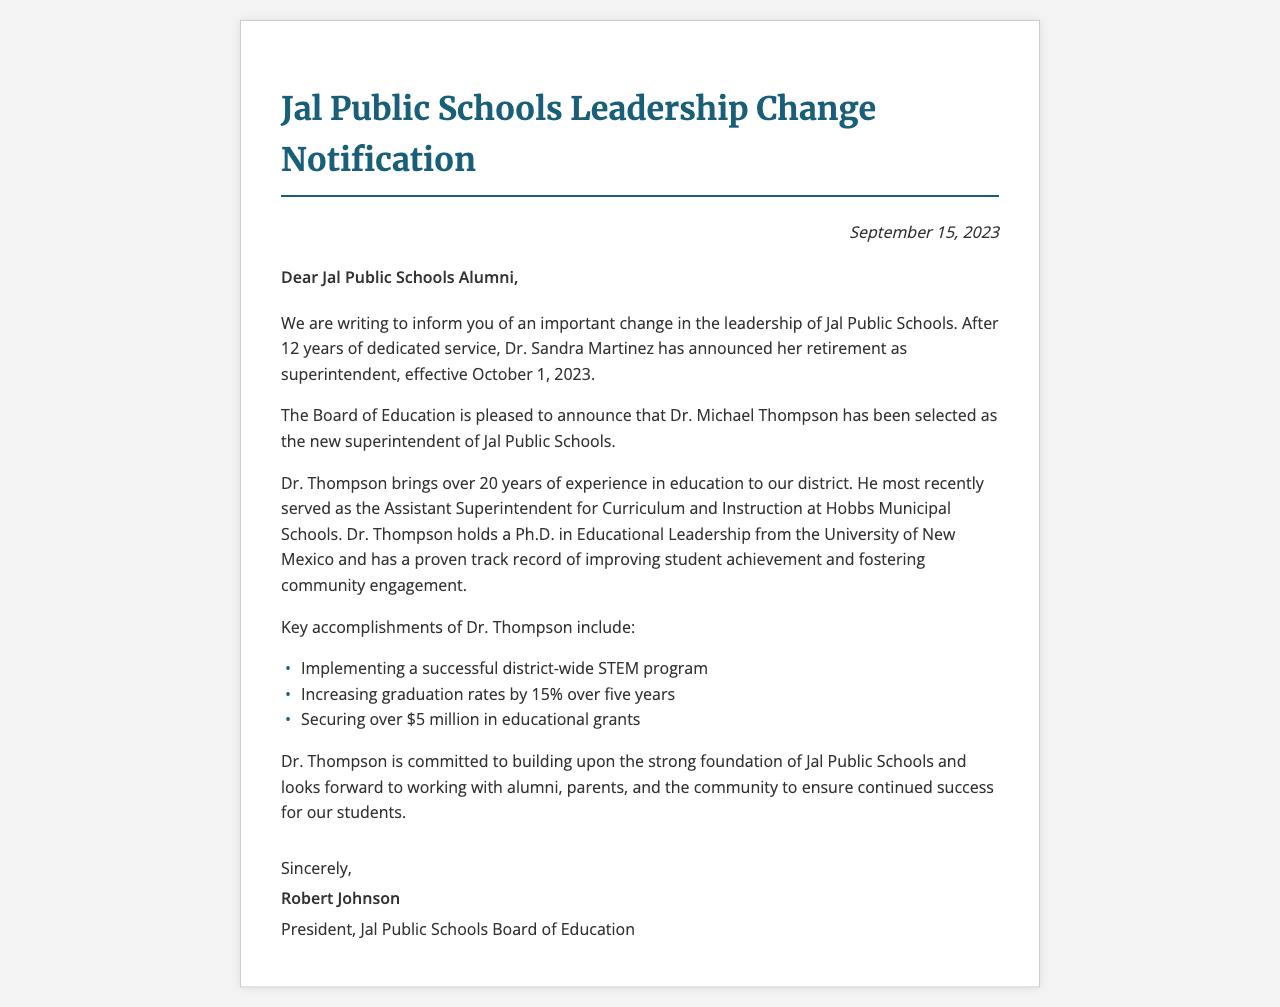What is the date of the notification? The date of the notification is clearly mentioned in the document.
Answer: September 15, 2023 Who announced their retirement? The document states who is retiring from their position as superintendent.
Answer: Dr. Sandra Martinez What is the effective date of Dr. Martinez's retirement? The document specifies when Dr. Martinez's retirement will take effect.
Answer: October 1, 2023 Who is the new superintendent? The name of the newly appointed superintendent is provided in the document.
Answer: Dr. Michael Thompson How many years of experience does Dr. Thompson have in education? The document outlines Dr. Thompson's years of experience in the education field.
Answer: Over 20 years Where did Dr. Thompson serve prior to his new position? The document mentions Dr. Thompson's previous role before being appointed superintendent.
Answer: Hobbs Municipal Schools What degree does Dr. Thompson hold? The document provides information about Dr. Thompson's academic qualification.
Answer: Ph.D. in Educational Leadership What is one key accomplishment of Dr. Thompson? The document lists some of Dr. Thompson's accomplishments in education.
Answer: Implementing a successful district-wide STEM program What is the goal of Dr. Thompson as the new superintendent? The document explains Dr. Thompson's aspirations for his role in the district.
Answer: Building upon the strong foundation of Jal Public Schools 